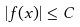<formula> <loc_0><loc_0><loc_500><loc_500>| f ( x ) | \leq C</formula> 